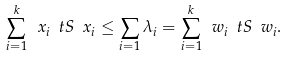Convert formula to latex. <formula><loc_0><loc_0><loc_500><loc_500>\sum _ { i = 1 } ^ { k } \ x _ { i } \ t S \ x _ { i } \leq \sum _ { i = 1 } \lambda _ { i } = \sum _ { i = 1 } ^ { k } \ w _ { i } \ t S \ w _ { i } .</formula> 